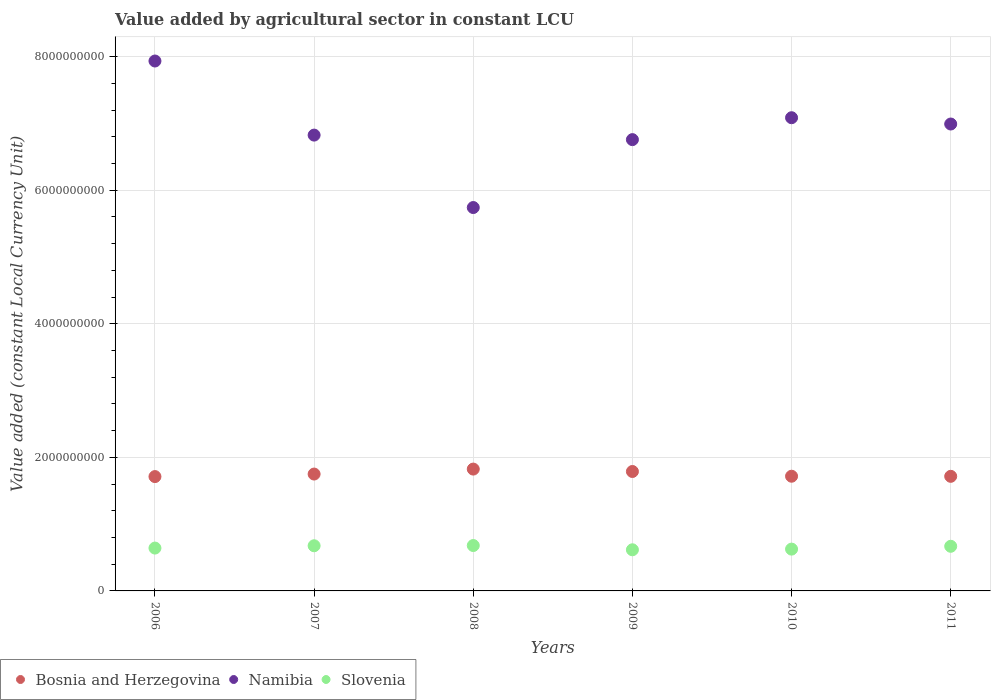What is the value added by agricultural sector in Namibia in 2011?
Offer a very short reply. 6.99e+09. Across all years, what is the maximum value added by agricultural sector in Namibia?
Offer a very short reply. 7.93e+09. Across all years, what is the minimum value added by agricultural sector in Bosnia and Herzegovina?
Your answer should be compact. 1.71e+09. In which year was the value added by agricultural sector in Namibia maximum?
Offer a very short reply. 2006. What is the total value added by agricultural sector in Bosnia and Herzegovina in the graph?
Offer a very short reply. 1.05e+1. What is the difference between the value added by agricultural sector in Slovenia in 2007 and that in 2008?
Your answer should be compact. -3.36e+06. What is the difference between the value added by agricultural sector in Bosnia and Herzegovina in 2011 and the value added by agricultural sector in Slovenia in 2007?
Offer a very short reply. 1.04e+09. What is the average value added by agricultural sector in Bosnia and Herzegovina per year?
Ensure brevity in your answer.  1.75e+09. In the year 2006, what is the difference between the value added by agricultural sector in Slovenia and value added by agricultural sector in Bosnia and Herzegovina?
Your response must be concise. -1.07e+09. In how many years, is the value added by agricultural sector in Slovenia greater than 3200000000 LCU?
Offer a terse response. 0. What is the ratio of the value added by agricultural sector in Bosnia and Herzegovina in 2006 to that in 2008?
Provide a succinct answer. 0.94. Is the value added by agricultural sector in Slovenia in 2009 less than that in 2011?
Provide a short and direct response. Yes. Is the difference between the value added by agricultural sector in Slovenia in 2009 and 2010 greater than the difference between the value added by agricultural sector in Bosnia and Herzegovina in 2009 and 2010?
Provide a short and direct response. No. What is the difference between the highest and the second highest value added by agricultural sector in Slovenia?
Your answer should be very brief. 3.36e+06. What is the difference between the highest and the lowest value added by agricultural sector in Namibia?
Offer a terse response. 2.19e+09. Is the sum of the value added by agricultural sector in Bosnia and Herzegovina in 2006 and 2011 greater than the maximum value added by agricultural sector in Namibia across all years?
Provide a succinct answer. No. Does the value added by agricultural sector in Bosnia and Herzegovina monotonically increase over the years?
Your answer should be very brief. No. Is the value added by agricultural sector in Bosnia and Herzegovina strictly greater than the value added by agricultural sector in Slovenia over the years?
Provide a succinct answer. Yes. Is the value added by agricultural sector in Namibia strictly less than the value added by agricultural sector in Bosnia and Herzegovina over the years?
Keep it short and to the point. No. Are the values on the major ticks of Y-axis written in scientific E-notation?
Offer a very short reply. No. Does the graph contain any zero values?
Your answer should be very brief. No. Does the graph contain grids?
Your answer should be compact. Yes. Where does the legend appear in the graph?
Your answer should be very brief. Bottom left. What is the title of the graph?
Your answer should be very brief. Value added by agricultural sector in constant LCU. What is the label or title of the X-axis?
Offer a terse response. Years. What is the label or title of the Y-axis?
Make the answer very short. Value added (constant Local Currency Unit). What is the Value added (constant Local Currency Unit) in Bosnia and Herzegovina in 2006?
Your response must be concise. 1.71e+09. What is the Value added (constant Local Currency Unit) in Namibia in 2006?
Your answer should be very brief. 7.93e+09. What is the Value added (constant Local Currency Unit) of Slovenia in 2006?
Provide a succinct answer. 6.42e+08. What is the Value added (constant Local Currency Unit) of Bosnia and Herzegovina in 2007?
Give a very brief answer. 1.75e+09. What is the Value added (constant Local Currency Unit) of Namibia in 2007?
Make the answer very short. 6.82e+09. What is the Value added (constant Local Currency Unit) of Slovenia in 2007?
Ensure brevity in your answer.  6.76e+08. What is the Value added (constant Local Currency Unit) in Bosnia and Herzegovina in 2008?
Offer a very short reply. 1.82e+09. What is the Value added (constant Local Currency Unit) in Namibia in 2008?
Offer a very short reply. 5.74e+09. What is the Value added (constant Local Currency Unit) in Slovenia in 2008?
Ensure brevity in your answer.  6.80e+08. What is the Value added (constant Local Currency Unit) in Bosnia and Herzegovina in 2009?
Make the answer very short. 1.79e+09. What is the Value added (constant Local Currency Unit) of Namibia in 2009?
Your response must be concise. 6.76e+09. What is the Value added (constant Local Currency Unit) in Slovenia in 2009?
Your answer should be very brief. 6.16e+08. What is the Value added (constant Local Currency Unit) of Bosnia and Herzegovina in 2010?
Make the answer very short. 1.72e+09. What is the Value added (constant Local Currency Unit) of Namibia in 2010?
Make the answer very short. 7.09e+09. What is the Value added (constant Local Currency Unit) of Slovenia in 2010?
Your answer should be very brief. 6.26e+08. What is the Value added (constant Local Currency Unit) of Bosnia and Herzegovina in 2011?
Provide a short and direct response. 1.72e+09. What is the Value added (constant Local Currency Unit) in Namibia in 2011?
Offer a terse response. 6.99e+09. What is the Value added (constant Local Currency Unit) of Slovenia in 2011?
Ensure brevity in your answer.  6.68e+08. Across all years, what is the maximum Value added (constant Local Currency Unit) of Bosnia and Herzegovina?
Keep it short and to the point. 1.82e+09. Across all years, what is the maximum Value added (constant Local Currency Unit) of Namibia?
Make the answer very short. 7.93e+09. Across all years, what is the maximum Value added (constant Local Currency Unit) of Slovenia?
Offer a terse response. 6.80e+08. Across all years, what is the minimum Value added (constant Local Currency Unit) in Bosnia and Herzegovina?
Provide a succinct answer. 1.71e+09. Across all years, what is the minimum Value added (constant Local Currency Unit) of Namibia?
Provide a succinct answer. 5.74e+09. Across all years, what is the minimum Value added (constant Local Currency Unit) in Slovenia?
Provide a short and direct response. 6.16e+08. What is the total Value added (constant Local Currency Unit) of Bosnia and Herzegovina in the graph?
Offer a terse response. 1.05e+1. What is the total Value added (constant Local Currency Unit) in Namibia in the graph?
Your response must be concise. 4.13e+1. What is the total Value added (constant Local Currency Unit) of Slovenia in the graph?
Ensure brevity in your answer.  3.91e+09. What is the difference between the Value added (constant Local Currency Unit) in Bosnia and Herzegovina in 2006 and that in 2007?
Your response must be concise. -3.79e+07. What is the difference between the Value added (constant Local Currency Unit) of Namibia in 2006 and that in 2007?
Your answer should be compact. 1.11e+09. What is the difference between the Value added (constant Local Currency Unit) of Slovenia in 2006 and that in 2007?
Your answer should be very brief. -3.47e+07. What is the difference between the Value added (constant Local Currency Unit) in Bosnia and Herzegovina in 2006 and that in 2008?
Provide a short and direct response. -1.12e+08. What is the difference between the Value added (constant Local Currency Unit) in Namibia in 2006 and that in 2008?
Keep it short and to the point. 2.19e+09. What is the difference between the Value added (constant Local Currency Unit) in Slovenia in 2006 and that in 2008?
Ensure brevity in your answer.  -3.80e+07. What is the difference between the Value added (constant Local Currency Unit) in Bosnia and Herzegovina in 2006 and that in 2009?
Offer a very short reply. -7.62e+07. What is the difference between the Value added (constant Local Currency Unit) in Namibia in 2006 and that in 2009?
Keep it short and to the point. 1.18e+09. What is the difference between the Value added (constant Local Currency Unit) in Slovenia in 2006 and that in 2009?
Your response must be concise. 2.57e+07. What is the difference between the Value added (constant Local Currency Unit) in Bosnia and Herzegovina in 2006 and that in 2010?
Your answer should be very brief. -5.34e+06. What is the difference between the Value added (constant Local Currency Unit) of Namibia in 2006 and that in 2010?
Give a very brief answer. 8.49e+08. What is the difference between the Value added (constant Local Currency Unit) of Slovenia in 2006 and that in 2010?
Offer a very short reply. 1.56e+07. What is the difference between the Value added (constant Local Currency Unit) in Bosnia and Herzegovina in 2006 and that in 2011?
Ensure brevity in your answer.  -3.84e+06. What is the difference between the Value added (constant Local Currency Unit) of Namibia in 2006 and that in 2011?
Keep it short and to the point. 9.43e+08. What is the difference between the Value added (constant Local Currency Unit) of Slovenia in 2006 and that in 2011?
Your answer should be compact. -2.67e+07. What is the difference between the Value added (constant Local Currency Unit) of Bosnia and Herzegovina in 2007 and that in 2008?
Offer a very short reply. -7.44e+07. What is the difference between the Value added (constant Local Currency Unit) in Namibia in 2007 and that in 2008?
Provide a short and direct response. 1.08e+09. What is the difference between the Value added (constant Local Currency Unit) of Slovenia in 2007 and that in 2008?
Ensure brevity in your answer.  -3.36e+06. What is the difference between the Value added (constant Local Currency Unit) of Bosnia and Herzegovina in 2007 and that in 2009?
Provide a short and direct response. -3.83e+07. What is the difference between the Value added (constant Local Currency Unit) in Namibia in 2007 and that in 2009?
Ensure brevity in your answer.  6.78e+07. What is the difference between the Value added (constant Local Currency Unit) of Slovenia in 2007 and that in 2009?
Keep it short and to the point. 6.04e+07. What is the difference between the Value added (constant Local Currency Unit) of Bosnia and Herzegovina in 2007 and that in 2010?
Keep it short and to the point. 3.25e+07. What is the difference between the Value added (constant Local Currency Unit) of Namibia in 2007 and that in 2010?
Your answer should be very brief. -2.60e+08. What is the difference between the Value added (constant Local Currency Unit) in Slovenia in 2007 and that in 2010?
Give a very brief answer. 5.02e+07. What is the difference between the Value added (constant Local Currency Unit) in Bosnia and Herzegovina in 2007 and that in 2011?
Your answer should be very brief. 3.40e+07. What is the difference between the Value added (constant Local Currency Unit) in Namibia in 2007 and that in 2011?
Provide a succinct answer. -1.66e+08. What is the difference between the Value added (constant Local Currency Unit) in Slovenia in 2007 and that in 2011?
Provide a succinct answer. 7.97e+06. What is the difference between the Value added (constant Local Currency Unit) of Bosnia and Herzegovina in 2008 and that in 2009?
Keep it short and to the point. 3.61e+07. What is the difference between the Value added (constant Local Currency Unit) of Namibia in 2008 and that in 2009?
Provide a short and direct response. -1.02e+09. What is the difference between the Value added (constant Local Currency Unit) of Slovenia in 2008 and that in 2009?
Your response must be concise. 6.37e+07. What is the difference between the Value added (constant Local Currency Unit) of Bosnia and Herzegovina in 2008 and that in 2010?
Your answer should be very brief. 1.07e+08. What is the difference between the Value added (constant Local Currency Unit) in Namibia in 2008 and that in 2010?
Your answer should be very brief. -1.34e+09. What is the difference between the Value added (constant Local Currency Unit) of Slovenia in 2008 and that in 2010?
Ensure brevity in your answer.  5.36e+07. What is the difference between the Value added (constant Local Currency Unit) of Bosnia and Herzegovina in 2008 and that in 2011?
Your response must be concise. 1.08e+08. What is the difference between the Value added (constant Local Currency Unit) of Namibia in 2008 and that in 2011?
Provide a short and direct response. -1.25e+09. What is the difference between the Value added (constant Local Currency Unit) in Slovenia in 2008 and that in 2011?
Offer a terse response. 1.13e+07. What is the difference between the Value added (constant Local Currency Unit) in Bosnia and Herzegovina in 2009 and that in 2010?
Offer a terse response. 7.09e+07. What is the difference between the Value added (constant Local Currency Unit) of Namibia in 2009 and that in 2010?
Your response must be concise. -3.28e+08. What is the difference between the Value added (constant Local Currency Unit) of Slovenia in 2009 and that in 2010?
Keep it short and to the point. -1.01e+07. What is the difference between the Value added (constant Local Currency Unit) of Bosnia and Herzegovina in 2009 and that in 2011?
Keep it short and to the point. 7.24e+07. What is the difference between the Value added (constant Local Currency Unit) of Namibia in 2009 and that in 2011?
Offer a very short reply. -2.34e+08. What is the difference between the Value added (constant Local Currency Unit) in Slovenia in 2009 and that in 2011?
Give a very brief answer. -5.24e+07. What is the difference between the Value added (constant Local Currency Unit) in Bosnia and Herzegovina in 2010 and that in 2011?
Offer a very short reply. 1.49e+06. What is the difference between the Value added (constant Local Currency Unit) in Namibia in 2010 and that in 2011?
Your response must be concise. 9.43e+07. What is the difference between the Value added (constant Local Currency Unit) in Slovenia in 2010 and that in 2011?
Offer a terse response. -4.23e+07. What is the difference between the Value added (constant Local Currency Unit) in Bosnia and Herzegovina in 2006 and the Value added (constant Local Currency Unit) in Namibia in 2007?
Give a very brief answer. -5.11e+09. What is the difference between the Value added (constant Local Currency Unit) of Bosnia and Herzegovina in 2006 and the Value added (constant Local Currency Unit) of Slovenia in 2007?
Ensure brevity in your answer.  1.04e+09. What is the difference between the Value added (constant Local Currency Unit) in Namibia in 2006 and the Value added (constant Local Currency Unit) in Slovenia in 2007?
Provide a short and direct response. 7.26e+09. What is the difference between the Value added (constant Local Currency Unit) in Bosnia and Herzegovina in 2006 and the Value added (constant Local Currency Unit) in Namibia in 2008?
Offer a terse response. -4.03e+09. What is the difference between the Value added (constant Local Currency Unit) of Bosnia and Herzegovina in 2006 and the Value added (constant Local Currency Unit) of Slovenia in 2008?
Your answer should be compact. 1.03e+09. What is the difference between the Value added (constant Local Currency Unit) of Namibia in 2006 and the Value added (constant Local Currency Unit) of Slovenia in 2008?
Provide a succinct answer. 7.25e+09. What is the difference between the Value added (constant Local Currency Unit) in Bosnia and Herzegovina in 2006 and the Value added (constant Local Currency Unit) in Namibia in 2009?
Provide a succinct answer. -5.05e+09. What is the difference between the Value added (constant Local Currency Unit) of Bosnia and Herzegovina in 2006 and the Value added (constant Local Currency Unit) of Slovenia in 2009?
Offer a terse response. 1.10e+09. What is the difference between the Value added (constant Local Currency Unit) in Namibia in 2006 and the Value added (constant Local Currency Unit) in Slovenia in 2009?
Your answer should be very brief. 7.32e+09. What is the difference between the Value added (constant Local Currency Unit) in Bosnia and Herzegovina in 2006 and the Value added (constant Local Currency Unit) in Namibia in 2010?
Offer a very short reply. -5.37e+09. What is the difference between the Value added (constant Local Currency Unit) of Bosnia and Herzegovina in 2006 and the Value added (constant Local Currency Unit) of Slovenia in 2010?
Give a very brief answer. 1.09e+09. What is the difference between the Value added (constant Local Currency Unit) in Namibia in 2006 and the Value added (constant Local Currency Unit) in Slovenia in 2010?
Keep it short and to the point. 7.31e+09. What is the difference between the Value added (constant Local Currency Unit) in Bosnia and Herzegovina in 2006 and the Value added (constant Local Currency Unit) in Namibia in 2011?
Your response must be concise. -5.28e+09. What is the difference between the Value added (constant Local Currency Unit) in Bosnia and Herzegovina in 2006 and the Value added (constant Local Currency Unit) in Slovenia in 2011?
Your response must be concise. 1.04e+09. What is the difference between the Value added (constant Local Currency Unit) in Namibia in 2006 and the Value added (constant Local Currency Unit) in Slovenia in 2011?
Give a very brief answer. 7.27e+09. What is the difference between the Value added (constant Local Currency Unit) of Bosnia and Herzegovina in 2007 and the Value added (constant Local Currency Unit) of Namibia in 2008?
Provide a succinct answer. -3.99e+09. What is the difference between the Value added (constant Local Currency Unit) in Bosnia and Herzegovina in 2007 and the Value added (constant Local Currency Unit) in Slovenia in 2008?
Make the answer very short. 1.07e+09. What is the difference between the Value added (constant Local Currency Unit) of Namibia in 2007 and the Value added (constant Local Currency Unit) of Slovenia in 2008?
Your response must be concise. 6.15e+09. What is the difference between the Value added (constant Local Currency Unit) of Bosnia and Herzegovina in 2007 and the Value added (constant Local Currency Unit) of Namibia in 2009?
Provide a succinct answer. -5.01e+09. What is the difference between the Value added (constant Local Currency Unit) in Bosnia and Herzegovina in 2007 and the Value added (constant Local Currency Unit) in Slovenia in 2009?
Keep it short and to the point. 1.13e+09. What is the difference between the Value added (constant Local Currency Unit) in Namibia in 2007 and the Value added (constant Local Currency Unit) in Slovenia in 2009?
Provide a succinct answer. 6.21e+09. What is the difference between the Value added (constant Local Currency Unit) of Bosnia and Herzegovina in 2007 and the Value added (constant Local Currency Unit) of Namibia in 2010?
Keep it short and to the point. -5.34e+09. What is the difference between the Value added (constant Local Currency Unit) in Bosnia and Herzegovina in 2007 and the Value added (constant Local Currency Unit) in Slovenia in 2010?
Offer a terse response. 1.12e+09. What is the difference between the Value added (constant Local Currency Unit) in Namibia in 2007 and the Value added (constant Local Currency Unit) in Slovenia in 2010?
Keep it short and to the point. 6.20e+09. What is the difference between the Value added (constant Local Currency Unit) in Bosnia and Herzegovina in 2007 and the Value added (constant Local Currency Unit) in Namibia in 2011?
Your answer should be compact. -5.24e+09. What is the difference between the Value added (constant Local Currency Unit) of Bosnia and Herzegovina in 2007 and the Value added (constant Local Currency Unit) of Slovenia in 2011?
Keep it short and to the point. 1.08e+09. What is the difference between the Value added (constant Local Currency Unit) of Namibia in 2007 and the Value added (constant Local Currency Unit) of Slovenia in 2011?
Offer a terse response. 6.16e+09. What is the difference between the Value added (constant Local Currency Unit) of Bosnia and Herzegovina in 2008 and the Value added (constant Local Currency Unit) of Namibia in 2009?
Your answer should be compact. -4.93e+09. What is the difference between the Value added (constant Local Currency Unit) in Bosnia and Herzegovina in 2008 and the Value added (constant Local Currency Unit) in Slovenia in 2009?
Your answer should be very brief. 1.21e+09. What is the difference between the Value added (constant Local Currency Unit) of Namibia in 2008 and the Value added (constant Local Currency Unit) of Slovenia in 2009?
Provide a short and direct response. 5.12e+09. What is the difference between the Value added (constant Local Currency Unit) of Bosnia and Herzegovina in 2008 and the Value added (constant Local Currency Unit) of Namibia in 2010?
Offer a terse response. -5.26e+09. What is the difference between the Value added (constant Local Currency Unit) in Bosnia and Herzegovina in 2008 and the Value added (constant Local Currency Unit) in Slovenia in 2010?
Offer a very short reply. 1.20e+09. What is the difference between the Value added (constant Local Currency Unit) in Namibia in 2008 and the Value added (constant Local Currency Unit) in Slovenia in 2010?
Provide a short and direct response. 5.11e+09. What is the difference between the Value added (constant Local Currency Unit) of Bosnia and Herzegovina in 2008 and the Value added (constant Local Currency Unit) of Namibia in 2011?
Provide a short and direct response. -5.17e+09. What is the difference between the Value added (constant Local Currency Unit) of Bosnia and Herzegovina in 2008 and the Value added (constant Local Currency Unit) of Slovenia in 2011?
Your answer should be very brief. 1.16e+09. What is the difference between the Value added (constant Local Currency Unit) of Namibia in 2008 and the Value added (constant Local Currency Unit) of Slovenia in 2011?
Your answer should be very brief. 5.07e+09. What is the difference between the Value added (constant Local Currency Unit) of Bosnia and Herzegovina in 2009 and the Value added (constant Local Currency Unit) of Namibia in 2010?
Your answer should be compact. -5.30e+09. What is the difference between the Value added (constant Local Currency Unit) in Bosnia and Herzegovina in 2009 and the Value added (constant Local Currency Unit) in Slovenia in 2010?
Provide a short and direct response. 1.16e+09. What is the difference between the Value added (constant Local Currency Unit) in Namibia in 2009 and the Value added (constant Local Currency Unit) in Slovenia in 2010?
Give a very brief answer. 6.13e+09. What is the difference between the Value added (constant Local Currency Unit) in Bosnia and Herzegovina in 2009 and the Value added (constant Local Currency Unit) in Namibia in 2011?
Provide a succinct answer. -5.20e+09. What is the difference between the Value added (constant Local Currency Unit) of Bosnia and Herzegovina in 2009 and the Value added (constant Local Currency Unit) of Slovenia in 2011?
Give a very brief answer. 1.12e+09. What is the difference between the Value added (constant Local Currency Unit) of Namibia in 2009 and the Value added (constant Local Currency Unit) of Slovenia in 2011?
Offer a terse response. 6.09e+09. What is the difference between the Value added (constant Local Currency Unit) in Bosnia and Herzegovina in 2010 and the Value added (constant Local Currency Unit) in Namibia in 2011?
Provide a succinct answer. -5.27e+09. What is the difference between the Value added (constant Local Currency Unit) of Bosnia and Herzegovina in 2010 and the Value added (constant Local Currency Unit) of Slovenia in 2011?
Give a very brief answer. 1.05e+09. What is the difference between the Value added (constant Local Currency Unit) in Namibia in 2010 and the Value added (constant Local Currency Unit) in Slovenia in 2011?
Your answer should be compact. 6.42e+09. What is the average Value added (constant Local Currency Unit) of Bosnia and Herzegovina per year?
Make the answer very short. 1.75e+09. What is the average Value added (constant Local Currency Unit) in Namibia per year?
Your answer should be compact. 6.89e+09. What is the average Value added (constant Local Currency Unit) of Slovenia per year?
Make the answer very short. 6.51e+08. In the year 2006, what is the difference between the Value added (constant Local Currency Unit) of Bosnia and Herzegovina and Value added (constant Local Currency Unit) of Namibia?
Provide a short and direct response. -6.22e+09. In the year 2006, what is the difference between the Value added (constant Local Currency Unit) of Bosnia and Herzegovina and Value added (constant Local Currency Unit) of Slovenia?
Make the answer very short. 1.07e+09. In the year 2006, what is the difference between the Value added (constant Local Currency Unit) of Namibia and Value added (constant Local Currency Unit) of Slovenia?
Your answer should be very brief. 7.29e+09. In the year 2007, what is the difference between the Value added (constant Local Currency Unit) of Bosnia and Herzegovina and Value added (constant Local Currency Unit) of Namibia?
Keep it short and to the point. -5.08e+09. In the year 2007, what is the difference between the Value added (constant Local Currency Unit) in Bosnia and Herzegovina and Value added (constant Local Currency Unit) in Slovenia?
Your answer should be very brief. 1.07e+09. In the year 2007, what is the difference between the Value added (constant Local Currency Unit) of Namibia and Value added (constant Local Currency Unit) of Slovenia?
Your answer should be compact. 6.15e+09. In the year 2008, what is the difference between the Value added (constant Local Currency Unit) in Bosnia and Herzegovina and Value added (constant Local Currency Unit) in Namibia?
Your answer should be very brief. -3.92e+09. In the year 2008, what is the difference between the Value added (constant Local Currency Unit) in Bosnia and Herzegovina and Value added (constant Local Currency Unit) in Slovenia?
Your response must be concise. 1.14e+09. In the year 2008, what is the difference between the Value added (constant Local Currency Unit) of Namibia and Value added (constant Local Currency Unit) of Slovenia?
Your answer should be compact. 5.06e+09. In the year 2009, what is the difference between the Value added (constant Local Currency Unit) of Bosnia and Herzegovina and Value added (constant Local Currency Unit) of Namibia?
Offer a terse response. -4.97e+09. In the year 2009, what is the difference between the Value added (constant Local Currency Unit) of Bosnia and Herzegovina and Value added (constant Local Currency Unit) of Slovenia?
Provide a succinct answer. 1.17e+09. In the year 2009, what is the difference between the Value added (constant Local Currency Unit) of Namibia and Value added (constant Local Currency Unit) of Slovenia?
Your answer should be compact. 6.14e+09. In the year 2010, what is the difference between the Value added (constant Local Currency Unit) in Bosnia and Herzegovina and Value added (constant Local Currency Unit) in Namibia?
Your response must be concise. -5.37e+09. In the year 2010, what is the difference between the Value added (constant Local Currency Unit) of Bosnia and Herzegovina and Value added (constant Local Currency Unit) of Slovenia?
Give a very brief answer. 1.09e+09. In the year 2010, what is the difference between the Value added (constant Local Currency Unit) of Namibia and Value added (constant Local Currency Unit) of Slovenia?
Ensure brevity in your answer.  6.46e+09. In the year 2011, what is the difference between the Value added (constant Local Currency Unit) in Bosnia and Herzegovina and Value added (constant Local Currency Unit) in Namibia?
Make the answer very short. -5.28e+09. In the year 2011, what is the difference between the Value added (constant Local Currency Unit) in Bosnia and Herzegovina and Value added (constant Local Currency Unit) in Slovenia?
Give a very brief answer. 1.05e+09. In the year 2011, what is the difference between the Value added (constant Local Currency Unit) of Namibia and Value added (constant Local Currency Unit) of Slovenia?
Your answer should be compact. 6.32e+09. What is the ratio of the Value added (constant Local Currency Unit) of Bosnia and Herzegovina in 2006 to that in 2007?
Your response must be concise. 0.98. What is the ratio of the Value added (constant Local Currency Unit) in Namibia in 2006 to that in 2007?
Provide a short and direct response. 1.16. What is the ratio of the Value added (constant Local Currency Unit) of Slovenia in 2006 to that in 2007?
Provide a succinct answer. 0.95. What is the ratio of the Value added (constant Local Currency Unit) of Bosnia and Herzegovina in 2006 to that in 2008?
Give a very brief answer. 0.94. What is the ratio of the Value added (constant Local Currency Unit) of Namibia in 2006 to that in 2008?
Ensure brevity in your answer.  1.38. What is the ratio of the Value added (constant Local Currency Unit) in Slovenia in 2006 to that in 2008?
Give a very brief answer. 0.94. What is the ratio of the Value added (constant Local Currency Unit) of Bosnia and Herzegovina in 2006 to that in 2009?
Provide a succinct answer. 0.96. What is the ratio of the Value added (constant Local Currency Unit) in Namibia in 2006 to that in 2009?
Your response must be concise. 1.17. What is the ratio of the Value added (constant Local Currency Unit) of Slovenia in 2006 to that in 2009?
Provide a short and direct response. 1.04. What is the ratio of the Value added (constant Local Currency Unit) in Namibia in 2006 to that in 2010?
Your answer should be very brief. 1.12. What is the ratio of the Value added (constant Local Currency Unit) in Slovenia in 2006 to that in 2010?
Offer a terse response. 1.02. What is the ratio of the Value added (constant Local Currency Unit) of Bosnia and Herzegovina in 2006 to that in 2011?
Offer a very short reply. 1. What is the ratio of the Value added (constant Local Currency Unit) in Namibia in 2006 to that in 2011?
Your answer should be compact. 1.13. What is the ratio of the Value added (constant Local Currency Unit) in Slovenia in 2006 to that in 2011?
Your response must be concise. 0.96. What is the ratio of the Value added (constant Local Currency Unit) of Bosnia and Herzegovina in 2007 to that in 2008?
Give a very brief answer. 0.96. What is the ratio of the Value added (constant Local Currency Unit) in Namibia in 2007 to that in 2008?
Your response must be concise. 1.19. What is the ratio of the Value added (constant Local Currency Unit) in Bosnia and Herzegovina in 2007 to that in 2009?
Your answer should be compact. 0.98. What is the ratio of the Value added (constant Local Currency Unit) in Namibia in 2007 to that in 2009?
Ensure brevity in your answer.  1.01. What is the ratio of the Value added (constant Local Currency Unit) of Slovenia in 2007 to that in 2009?
Ensure brevity in your answer.  1.1. What is the ratio of the Value added (constant Local Currency Unit) in Namibia in 2007 to that in 2010?
Offer a terse response. 0.96. What is the ratio of the Value added (constant Local Currency Unit) in Slovenia in 2007 to that in 2010?
Your response must be concise. 1.08. What is the ratio of the Value added (constant Local Currency Unit) of Bosnia and Herzegovina in 2007 to that in 2011?
Offer a terse response. 1.02. What is the ratio of the Value added (constant Local Currency Unit) in Namibia in 2007 to that in 2011?
Provide a short and direct response. 0.98. What is the ratio of the Value added (constant Local Currency Unit) of Slovenia in 2007 to that in 2011?
Offer a terse response. 1.01. What is the ratio of the Value added (constant Local Currency Unit) of Bosnia and Herzegovina in 2008 to that in 2009?
Keep it short and to the point. 1.02. What is the ratio of the Value added (constant Local Currency Unit) of Namibia in 2008 to that in 2009?
Offer a very short reply. 0.85. What is the ratio of the Value added (constant Local Currency Unit) of Slovenia in 2008 to that in 2009?
Offer a very short reply. 1.1. What is the ratio of the Value added (constant Local Currency Unit) in Bosnia and Herzegovina in 2008 to that in 2010?
Make the answer very short. 1.06. What is the ratio of the Value added (constant Local Currency Unit) in Namibia in 2008 to that in 2010?
Provide a short and direct response. 0.81. What is the ratio of the Value added (constant Local Currency Unit) in Slovenia in 2008 to that in 2010?
Offer a very short reply. 1.09. What is the ratio of the Value added (constant Local Currency Unit) of Bosnia and Herzegovina in 2008 to that in 2011?
Keep it short and to the point. 1.06. What is the ratio of the Value added (constant Local Currency Unit) in Namibia in 2008 to that in 2011?
Your answer should be very brief. 0.82. What is the ratio of the Value added (constant Local Currency Unit) of Slovenia in 2008 to that in 2011?
Give a very brief answer. 1.02. What is the ratio of the Value added (constant Local Currency Unit) in Bosnia and Herzegovina in 2009 to that in 2010?
Make the answer very short. 1.04. What is the ratio of the Value added (constant Local Currency Unit) in Namibia in 2009 to that in 2010?
Provide a short and direct response. 0.95. What is the ratio of the Value added (constant Local Currency Unit) in Slovenia in 2009 to that in 2010?
Ensure brevity in your answer.  0.98. What is the ratio of the Value added (constant Local Currency Unit) of Bosnia and Herzegovina in 2009 to that in 2011?
Give a very brief answer. 1.04. What is the ratio of the Value added (constant Local Currency Unit) in Namibia in 2009 to that in 2011?
Provide a short and direct response. 0.97. What is the ratio of the Value added (constant Local Currency Unit) of Slovenia in 2009 to that in 2011?
Your response must be concise. 0.92. What is the ratio of the Value added (constant Local Currency Unit) in Bosnia and Herzegovina in 2010 to that in 2011?
Provide a short and direct response. 1. What is the ratio of the Value added (constant Local Currency Unit) in Namibia in 2010 to that in 2011?
Ensure brevity in your answer.  1.01. What is the ratio of the Value added (constant Local Currency Unit) of Slovenia in 2010 to that in 2011?
Your answer should be very brief. 0.94. What is the difference between the highest and the second highest Value added (constant Local Currency Unit) of Bosnia and Herzegovina?
Provide a short and direct response. 3.61e+07. What is the difference between the highest and the second highest Value added (constant Local Currency Unit) in Namibia?
Offer a very short reply. 8.49e+08. What is the difference between the highest and the second highest Value added (constant Local Currency Unit) in Slovenia?
Give a very brief answer. 3.36e+06. What is the difference between the highest and the lowest Value added (constant Local Currency Unit) in Bosnia and Herzegovina?
Keep it short and to the point. 1.12e+08. What is the difference between the highest and the lowest Value added (constant Local Currency Unit) of Namibia?
Give a very brief answer. 2.19e+09. What is the difference between the highest and the lowest Value added (constant Local Currency Unit) in Slovenia?
Your response must be concise. 6.37e+07. 